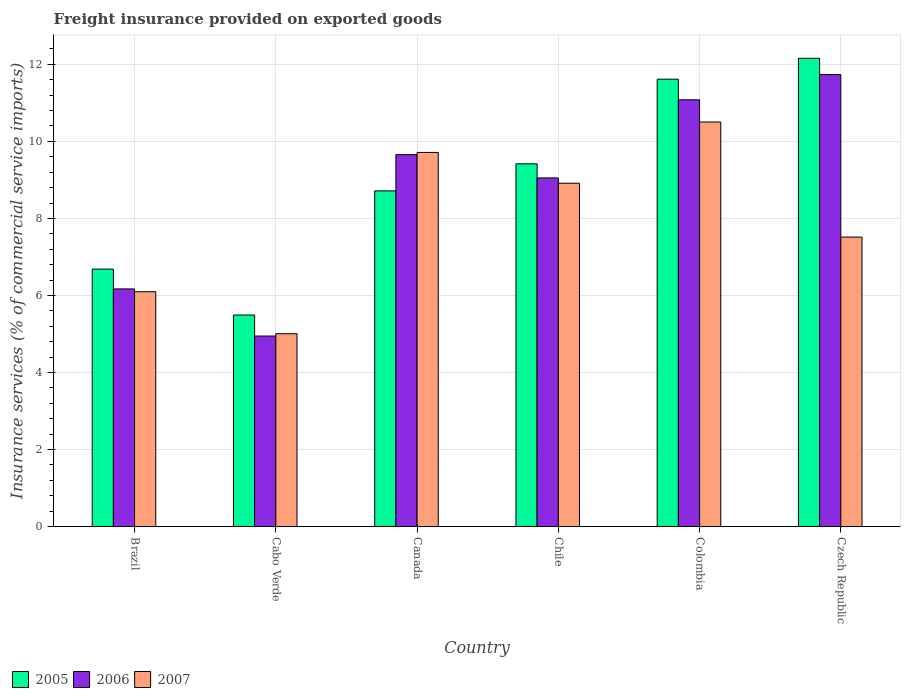How many groups of bars are there?
Your answer should be compact. 6. Are the number of bars per tick equal to the number of legend labels?
Make the answer very short. Yes. How many bars are there on the 2nd tick from the left?
Make the answer very short. 3. In how many cases, is the number of bars for a given country not equal to the number of legend labels?
Your answer should be very brief. 0. What is the freight insurance provided on exported goods in 2006 in Chile?
Offer a terse response. 9.05. Across all countries, what is the maximum freight insurance provided on exported goods in 2006?
Keep it short and to the point. 11.73. Across all countries, what is the minimum freight insurance provided on exported goods in 2005?
Your answer should be compact. 5.49. In which country was the freight insurance provided on exported goods in 2007 maximum?
Give a very brief answer. Colombia. In which country was the freight insurance provided on exported goods in 2007 minimum?
Your answer should be compact. Cabo Verde. What is the total freight insurance provided on exported goods in 2006 in the graph?
Offer a very short reply. 52.64. What is the difference between the freight insurance provided on exported goods in 2005 in Cabo Verde and that in Colombia?
Your answer should be compact. -6.12. What is the difference between the freight insurance provided on exported goods in 2005 in Chile and the freight insurance provided on exported goods in 2007 in Czech Republic?
Your answer should be very brief. 1.9. What is the average freight insurance provided on exported goods in 2005 per country?
Ensure brevity in your answer.  9.01. What is the difference between the freight insurance provided on exported goods of/in 2005 and freight insurance provided on exported goods of/in 2007 in Czech Republic?
Ensure brevity in your answer.  4.64. In how many countries, is the freight insurance provided on exported goods in 2006 greater than 11.2 %?
Offer a terse response. 1. What is the ratio of the freight insurance provided on exported goods in 2006 in Colombia to that in Czech Republic?
Ensure brevity in your answer.  0.94. Is the freight insurance provided on exported goods in 2005 in Brazil less than that in Canada?
Give a very brief answer. Yes. What is the difference between the highest and the second highest freight insurance provided on exported goods in 2007?
Provide a succinct answer. -0.8. What is the difference between the highest and the lowest freight insurance provided on exported goods in 2006?
Give a very brief answer. 6.79. In how many countries, is the freight insurance provided on exported goods in 2007 greater than the average freight insurance provided on exported goods in 2007 taken over all countries?
Make the answer very short. 3. Is the sum of the freight insurance provided on exported goods in 2005 in Brazil and Czech Republic greater than the maximum freight insurance provided on exported goods in 2007 across all countries?
Offer a very short reply. Yes. What does the 2nd bar from the right in Cabo Verde represents?
Keep it short and to the point. 2006. Is it the case that in every country, the sum of the freight insurance provided on exported goods in 2007 and freight insurance provided on exported goods in 2005 is greater than the freight insurance provided on exported goods in 2006?
Offer a very short reply. Yes. How many bars are there?
Offer a very short reply. 18. How many countries are there in the graph?
Provide a succinct answer. 6. What is the difference between two consecutive major ticks on the Y-axis?
Offer a very short reply. 2. Are the values on the major ticks of Y-axis written in scientific E-notation?
Offer a terse response. No. Does the graph contain grids?
Provide a short and direct response. Yes. How many legend labels are there?
Ensure brevity in your answer.  3. What is the title of the graph?
Ensure brevity in your answer.  Freight insurance provided on exported goods. What is the label or title of the X-axis?
Provide a short and direct response. Country. What is the label or title of the Y-axis?
Your answer should be compact. Insurance services (% of commercial service imports). What is the Insurance services (% of commercial service imports) of 2005 in Brazil?
Offer a terse response. 6.68. What is the Insurance services (% of commercial service imports) of 2006 in Brazil?
Make the answer very short. 6.17. What is the Insurance services (% of commercial service imports) in 2007 in Brazil?
Offer a very short reply. 6.1. What is the Insurance services (% of commercial service imports) in 2005 in Cabo Verde?
Make the answer very short. 5.49. What is the Insurance services (% of commercial service imports) of 2006 in Cabo Verde?
Keep it short and to the point. 4.95. What is the Insurance services (% of commercial service imports) in 2007 in Cabo Verde?
Offer a terse response. 5.01. What is the Insurance services (% of commercial service imports) in 2005 in Canada?
Your response must be concise. 8.72. What is the Insurance services (% of commercial service imports) of 2006 in Canada?
Make the answer very short. 9.66. What is the Insurance services (% of commercial service imports) in 2007 in Canada?
Your response must be concise. 9.71. What is the Insurance services (% of commercial service imports) in 2005 in Chile?
Give a very brief answer. 9.42. What is the Insurance services (% of commercial service imports) of 2006 in Chile?
Offer a very short reply. 9.05. What is the Insurance services (% of commercial service imports) of 2007 in Chile?
Provide a short and direct response. 8.91. What is the Insurance services (% of commercial service imports) in 2005 in Colombia?
Give a very brief answer. 11.62. What is the Insurance services (% of commercial service imports) in 2006 in Colombia?
Offer a very short reply. 11.08. What is the Insurance services (% of commercial service imports) of 2007 in Colombia?
Your answer should be very brief. 10.5. What is the Insurance services (% of commercial service imports) of 2005 in Czech Republic?
Keep it short and to the point. 12.16. What is the Insurance services (% of commercial service imports) of 2006 in Czech Republic?
Provide a short and direct response. 11.73. What is the Insurance services (% of commercial service imports) of 2007 in Czech Republic?
Keep it short and to the point. 7.51. Across all countries, what is the maximum Insurance services (% of commercial service imports) in 2005?
Keep it short and to the point. 12.16. Across all countries, what is the maximum Insurance services (% of commercial service imports) in 2006?
Give a very brief answer. 11.73. Across all countries, what is the maximum Insurance services (% of commercial service imports) in 2007?
Keep it short and to the point. 10.5. Across all countries, what is the minimum Insurance services (% of commercial service imports) in 2005?
Your answer should be compact. 5.49. Across all countries, what is the minimum Insurance services (% of commercial service imports) of 2006?
Provide a short and direct response. 4.95. Across all countries, what is the minimum Insurance services (% of commercial service imports) in 2007?
Give a very brief answer. 5.01. What is the total Insurance services (% of commercial service imports) in 2005 in the graph?
Provide a short and direct response. 54.08. What is the total Insurance services (% of commercial service imports) in 2006 in the graph?
Your answer should be very brief. 52.64. What is the total Insurance services (% of commercial service imports) in 2007 in the graph?
Your answer should be compact. 47.75. What is the difference between the Insurance services (% of commercial service imports) of 2005 in Brazil and that in Cabo Verde?
Keep it short and to the point. 1.19. What is the difference between the Insurance services (% of commercial service imports) in 2006 in Brazil and that in Cabo Verde?
Provide a short and direct response. 1.22. What is the difference between the Insurance services (% of commercial service imports) in 2007 in Brazil and that in Cabo Verde?
Keep it short and to the point. 1.09. What is the difference between the Insurance services (% of commercial service imports) of 2005 in Brazil and that in Canada?
Your response must be concise. -2.03. What is the difference between the Insurance services (% of commercial service imports) in 2006 in Brazil and that in Canada?
Provide a short and direct response. -3.49. What is the difference between the Insurance services (% of commercial service imports) of 2007 in Brazil and that in Canada?
Provide a succinct answer. -3.62. What is the difference between the Insurance services (% of commercial service imports) in 2005 in Brazil and that in Chile?
Make the answer very short. -2.73. What is the difference between the Insurance services (% of commercial service imports) in 2006 in Brazil and that in Chile?
Your response must be concise. -2.88. What is the difference between the Insurance services (% of commercial service imports) in 2007 in Brazil and that in Chile?
Keep it short and to the point. -2.82. What is the difference between the Insurance services (% of commercial service imports) in 2005 in Brazil and that in Colombia?
Provide a short and direct response. -4.93. What is the difference between the Insurance services (% of commercial service imports) of 2006 in Brazil and that in Colombia?
Give a very brief answer. -4.91. What is the difference between the Insurance services (% of commercial service imports) in 2007 in Brazil and that in Colombia?
Provide a short and direct response. -4.41. What is the difference between the Insurance services (% of commercial service imports) of 2005 in Brazil and that in Czech Republic?
Make the answer very short. -5.47. What is the difference between the Insurance services (% of commercial service imports) in 2006 in Brazil and that in Czech Republic?
Offer a terse response. -5.57. What is the difference between the Insurance services (% of commercial service imports) of 2007 in Brazil and that in Czech Republic?
Offer a very short reply. -1.42. What is the difference between the Insurance services (% of commercial service imports) of 2005 in Cabo Verde and that in Canada?
Provide a succinct answer. -3.22. What is the difference between the Insurance services (% of commercial service imports) of 2006 in Cabo Verde and that in Canada?
Keep it short and to the point. -4.71. What is the difference between the Insurance services (% of commercial service imports) in 2007 in Cabo Verde and that in Canada?
Make the answer very short. -4.71. What is the difference between the Insurance services (% of commercial service imports) of 2005 in Cabo Verde and that in Chile?
Offer a terse response. -3.93. What is the difference between the Insurance services (% of commercial service imports) of 2006 in Cabo Verde and that in Chile?
Give a very brief answer. -4.11. What is the difference between the Insurance services (% of commercial service imports) of 2007 in Cabo Verde and that in Chile?
Your answer should be very brief. -3.91. What is the difference between the Insurance services (% of commercial service imports) in 2005 in Cabo Verde and that in Colombia?
Keep it short and to the point. -6.12. What is the difference between the Insurance services (% of commercial service imports) in 2006 in Cabo Verde and that in Colombia?
Your response must be concise. -6.13. What is the difference between the Insurance services (% of commercial service imports) of 2007 in Cabo Verde and that in Colombia?
Make the answer very short. -5.5. What is the difference between the Insurance services (% of commercial service imports) of 2005 in Cabo Verde and that in Czech Republic?
Make the answer very short. -6.67. What is the difference between the Insurance services (% of commercial service imports) of 2006 in Cabo Verde and that in Czech Republic?
Make the answer very short. -6.79. What is the difference between the Insurance services (% of commercial service imports) in 2007 in Cabo Verde and that in Czech Republic?
Offer a terse response. -2.51. What is the difference between the Insurance services (% of commercial service imports) of 2005 in Canada and that in Chile?
Give a very brief answer. -0.7. What is the difference between the Insurance services (% of commercial service imports) of 2006 in Canada and that in Chile?
Your response must be concise. 0.6. What is the difference between the Insurance services (% of commercial service imports) of 2007 in Canada and that in Chile?
Your answer should be compact. 0.8. What is the difference between the Insurance services (% of commercial service imports) of 2006 in Canada and that in Colombia?
Your response must be concise. -1.42. What is the difference between the Insurance services (% of commercial service imports) of 2007 in Canada and that in Colombia?
Your response must be concise. -0.79. What is the difference between the Insurance services (% of commercial service imports) in 2005 in Canada and that in Czech Republic?
Give a very brief answer. -3.44. What is the difference between the Insurance services (% of commercial service imports) of 2006 in Canada and that in Czech Republic?
Your answer should be very brief. -2.08. What is the difference between the Insurance services (% of commercial service imports) in 2007 in Canada and that in Czech Republic?
Offer a very short reply. 2.2. What is the difference between the Insurance services (% of commercial service imports) of 2005 in Chile and that in Colombia?
Your answer should be compact. -2.2. What is the difference between the Insurance services (% of commercial service imports) in 2006 in Chile and that in Colombia?
Ensure brevity in your answer.  -2.03. What is the difference between the Insurance services (% of commercial service imports) of 2007 in Chile and that in Colombia?
Your answer should be compact. -1.59. What is the difference between the Insurance services (% of commercial service imports) of 2005 in Chile and that in Czech Republic?
Keep it short and to the point. -2.74. What is the difference between the Insurance services (% of commercial service imports) in 2006 in Chile and that in Czech Republic?
Offer a very short reply. -2.68. What is the difference between the Insurance services (% of commercial service imports) of 2007 in Chile and that in Czech Republic?
Make the answer very short. 1.4. What is the difference between the Insurance services (% of commercial service imports) in 2005 in Colombia and that in Czech Republic?
Your answer should be compact. -0.54. What is the difference between the Insurance services (% of commercial service imports) of 2006 in Colombia and that in Czech Republic?
Ensure brevity in your answer.  -0.66. What is the difference between the Insurance services (% of commercial service imports) of 2007 in Colombia and that in Czech Republic?
Your answer should be very brief. 2.99. What is the difference between the Insurance services (% of commercial service imports) of 2005 in Brazil and the Insurance services (% of commercial service imports) of 2006 in Cabo Verde?
Ensure brevity in your answer.  1.74. What is the difference between the Insurance services (% of commercial service imports) of 2005 in Brazil and the Insurance services (% of commercial service imports) of 2007 in Cabo Verde?
Give a very brief answer. 1.68. What is the difference between the Insurance services (% of commercial service imports) of 2006 in Brazil and the Insurance services (% of commercial service imports) of 2007 in Cabo Verde?
Make the answer very short. 1.16. What is the difference between the Insurance services (% of commercial service imports) of 2005 in Brazil and the Insurance services (% of commercial service imports) of 2006 in Canada?
Keep it short and to the point. -2.97. What is the difference between the Insurance services (% of commercial service imports) in 2005 in Brazil and the Insurance services (% of commercial service imports) in 2007 in Canada?
Ensure brevity in your answer.  -3.03. What is the difference between the Insurance services (% of commercial service imports) of 2006 in Brazil and the Insurance services (% of commercial service imports) of 2007 in Canada?
Provide a short and direct response. -3.54. What is the difference between the Insurance services (% of commercial service imports) in 2005 in Brazil and the Insurance services (% of commercial service imports) in 2006 in Chile?
Ensure brevity in your answer.  -2.37. What is the difference between the Insurance services (% of commercial service imports) of 2005 in Brazil and the Insurance services (% of commercial service imports) of 2007 in Chile?
Your answer should be compact. -2.23. What is the difference between the Insurance services (% of commercial service imports) in 2006 in Brazil and the Insurance services (% of commercial service imports) in 2007 in Chile?
Give a very brief answer. -2.74. What is the difference between the Insurance services (% of commercial service imports) of 2005 in Brazil and the Insurance services (% of commercial service imports) of 2006 in Colombia?
Provide a succinct answer. -4.4. What is the difference between the Insurance services (% of commercial service imports) of 2005 in Brazil and the Insurance services (% of commercial service imports) of 2007 in Colombia?
Your response must be concise. -3.82. What is the difference between the Insurance services (% of commercial service imports) in 2006 in Brazil and the Insurance services (% of commercial service imports) in 2007 in Colombia?
Make the answer very short. -4.33. What is the difference between the Insurance services (% of commercial service imports) in 2005 in Brazil and the Insurance services (% of commercial service imports) in 2006 in Czech Republic?
Offer a very short reply. -5.05. What is the difference between the Insurance services (% of commercial service imports) of 2005 in Brazil and the Insurance services (% of commercial service imports) of 2007 in Czech Republic?
Make the answer very short. -0.83. What is the difference between the Insurance services (% of commercial service imports) of 2006 in Brazil and the Insurance services (% of commercial service imports) of 2007 in Czech Republic?
Provide a short and direct response. -1.35. What is the difference between the Insurance services (% of commercial service imports) in 2005 in Cabo Verde and the Insurance services (% of commercial service imports) in 2006 in Canada?
Provide a short and direct response. -4.16. What is the difference between the Insurance services (% of commercial service imports) in 2005 in Cabo Verde and the Insurance services (% of commercial service imports) in 2007 in Canada?
Give a very brief answer. -4.22. What is the difference between the Insurance services (% of commercial service imports) in 2006 in Cabo Verde and the Insurance services (% of commercial service imports) in 2007 in Canada?
Keep it short and to the point. -4.77. What is the difference between the Insurance services (% of commercial service imports) in 2005 in Cabo Verde and the Insurance services (% of commercial service imports) in 2006 in Chile?
Your answer should be compact. -3.56. What is the difference between the Insurance services (% of commercial service imports) of 2005 in Cabo Verde and the Insurance services (% of commercial service imports) of 2007 in Chile?
Offer a terse response. -3.42. What is the difference between the Insurance services (% of commercial service imports) of 2006 in Cabo Verde and the Insurance services (% of commercial service imports) of 2007 in Chile?
Offer a terse response. -3.97. What is the difference between the Insurance services (% of commercial service imports) in 2005 in Cabo Verde and the Insurance services (% of commercial service imports) in 2006 in Colombia?
Your answer should be compact. -5.59. What is the difference between the Insurance services (% of commercial service imports) of 2005 in Cabo Verde and the Insurance services (% of commercial service imports) of 2007 in Colombia?
Give a very brief answer. -5.01. What is the difference between the Insurance services (% of commercial service imports) of 2006 in Cabo Verde and the Insurance services (% of commercial service imports) of 2007 in Colombia?
Offer a very short reply. -5.56. What is the difference between the Insurance services (% of commercial service imports) in 2005 in Cabo Verde and the Insurance services (% of commercial service imports) in 2006 in Czech Republic?
Your answer should be compact. -6.24. What is the difference between the Insurance services (% of commercial service imports) in 2005 in Cabo Verde and the Insurance services (% of commercial service imports) in 2007 in Czech Republic?
Make the answer very short. -2.02. What is the difference between the Insurance services (% of commercial service imports) of 2006 in Cabo Verde and the Insurance services (% of commercial service imports) of 2007 in Czech Republic?
Offer a terse response. -2.57. What is the difference between the Insurance services (% of commercial service imports) of 2005 in Canada and the Insurance services (% of commercial service imports) of 2006 in Chile?
Keep it short and to the point. -0.34. What is the difference between the Insurance services (% of commercial service imports) of 2005 in Canada and the Insurance services (% of commercial service imports) of 2007 in Chile?
Ensure brevity in your answer.  -0.2. What is the difference between the Insurance services (% of commercial service imports) of 2006 in Canada and the Insurance services (% of commercial service imports) of 2007 in Chile?
Provide a succinct answer. 0.74. What is the difference between the Insurance services (% of commercial service imports) in 2005 in Canada and the Insurance services (% of commercial service imports) in 2006 in Colombia?
Your answer should be compact. -2.36. What is the difference between the Insurance services (% of commercial service imports) of 2005 in Canada and the Insurance services (% of commercial service imports) of 2007 in Colombia?
Your answer should be compact. -1.79. What is the difference between the Insurance services (% of commercial service imports) in 2006 in Canada and the Insurance services (% of commercial service imports) in 2007 in Colombia?
Provide a short and direct response. -0.85. What is the difference between the Insurance services (% of commercial service imports) in 2005 in Canada and the Insurance services (% of commercial service imports) in 2006 in Czech Republic?
Keep it short and to the point. -3.02. What is the difference between the Insurance services (% of commercial service imports) in 2005 in Canada and the Insurance services (% of commercial service imports) in 2007 in Czech Republic?
Make the answer very short. 1.2. What is the difference between the Insurance services (% of commercial service imports) of 2006 in Canada and the Insurance services (% of commercial service imports) of 2007 in Czech Republic?
Your answer should be very brief. 2.14. What is the difference between the Insurance services (% of commercial service imports) in 2005 in Chile and the Insurance services (% of commercial service imports) in 2006 in Colombia?
Your response must be concise. -1.66. What is the difference between the Insurance services (% of commercial service imports) of 2005 in Chile and the Insurance services (% of commercial service imports) of 2007 in Colombia?
Offer a very short reply. -1.09. What is the difference between the Insurance services (% of commercial service imports) in 2006 in Chile and the Insurance services (% of commercial service imports) in 2007 in Colombia?
Give a very brief answer. -1.45. What is the difference between the Insurance services (% of commercial service imports) in 2005 in Chile and the Insurance services (% of commercial service imports) in 2006 in Czech Republic?
Keep it short and to the point. -2.32. What is the difference between the Insurance services (% of commercial service imports) of 2005 in Chile and the Insurance services (% of commercial service imports) of 2007 in Czech Republic?
Your response must be concise. 1.9. What is the difference between the Insurance services (% of commercial service imports) of 2006 in Chile and the Insurance services (% of commercial service imports) of 2007 in Czech Republic?
Ensure brevity in your answer.  1.54. What is the difference between the Insurance services (% of commercial service imports) in 2005 in Colombia and the Insurance services (% of commercial service imports) in 2006 in Czech Republic?
Offer a very short reply. -0.12. What is the difference between the Insurance services (% of commercial service imports) of 2005 in Colombia and the Insurance services (% of commercial service imports) of 2007 in Czech Republic?
Offer a very short reply. 4.1. What is the difference between the Insurance services (% of commercial service imports) in 2006 in Colombia and the Insurance services (% of commercial service imports) in 2007 in Czech Republic?
Provide a succinct answer. 3.56. What is the average Insurance services (% of commercial service imports) of 2005 per country?
Give a very brief answer. 9.01. What is the average Insurance services (% of commercial service imports) of 2006 per country?
Provide a short and direct response. 8.77. What is the average Insurance services (% of commercial service imports) in 2007 per country?
Offer a terse response. 7.96. What is the difference between the Insurance services (% of commercial service imports) in 2005 and Insurance services (% of commercial service imports) in 2006 in Brazil?
Keep it short and to the point. 0.51. What is the difference between the Insurance services (% of commercial service imports) of 2005 and Insurance services (% of commercial service imports) of 2007 in Brazil?
Offer a terse response. 0.59. What is the difference between the Insurance services (% of commercial service imports) in 2006 and Insurance services (% of commercial service imports) in 2007 in Brazil?
Ensure brevity in your answer.  0.07. What is the difference between the Insurance services (% of commercial service imports) of 2005 and Insurance services (% of commercial service imports) of 2006 in Cabo Verde?
Your answer should be compact. 0.55. What is the difference between the Insurance services (% of commercial service imports) in 2005 and Insurance services (% of commercial service imports) in 2007 in Cabo Verde?
Keep it short and to the point. 0.49. What is the difference between the Insurance services (% of commercial service imports) in 2006 and Insurance services (% of commercial service imports) in 2007 in Cabo Verde?
Make the answer very short. -0.06. What is the difference between the Insurance services (% of commercial service imports) in 2005 and Insurance services (% of commercial service imports) in 2006 in Canada?
Your response must be concise. -0.94. What is the difference between the Insurance services (% of commercial service imports) of 2005 and Insurance services (% of commercial service imports) of 2007 in Canada?
Give a very brief answer. -1. What is the difference between the Insurance services (% of commercial service imports) of 2006 and Insurance services (% of commercial service imports) of 2007 in Canada?
Offer a very short reply. -0.06. What is the difference between the Insurance services (% of commercial service imports) in 2005 and Insurance services (% of commercial service imports) in 2006 in Chile?
Provide a short and direct response. 0.37. What is the difference between the Insurance services (% of commercial service imports) of 2005 and Insurance services (% of commercial service imports) of 2007 in Chile?
Offer a terse response. 0.5. What is the difference between the Insurance services (% of commercial service imports) in 2006 and Insurance services (% of commercial service imports) in 2007 in Chile?
Offer a very short reply. 0.14. What is the difference between the Insurance services (% of commercial service imports) of 2005 and Insurance services (% of commercial service imports) of 2006 in Colombia?
Offer a very short reply. 0.54. What is the difference between the Insurance services (% of commercial service imports) of 2005 and Insurance services (% of commercial service imports) of 2007 in Colombia?
Provide a short and direct response. 1.11. What is the difference between the Insurance services (% of commercial service imports) of 2006 and Insurance services (% of commercial service imports) of 2007 in Colombia?
Provide a succinct answer. 0.58. What is the difference between the Insurance services (% of commercial service imports) in 2005 and Insurance services (% of commercial service imports) in 2006 in Czech Republic?
Offer a very short reply. 0.42. What is the difference between the Insurance services (% of commercial service imports) of 2005 and Insurance services (% of commercial service imports) of 2007 in Czech Republic?
Your response must be concise. 4.64. What is the difference between the Insurance services (% of commercial service imports) of 2006 and Insurance services (% of commercial service imports) of 2007 in Czech Republic?
Provide a succinct answer. 4.22. What is the ratio of the Insurance services (% of commercial service imports) in 2005 in Brazil to that in Cabo Verde?
Ensure brevity in your answer.  1.22. What is the ratio of the Insurance services (% of commercial service imports) in 2006 in Brazil to that in Cabo Verde?
Give a very brief answer. 1.25. What is the ratio of the Insurance services (% of commercial service imports) of 2007 in Brazil to that in Cabo Verde?
Your answer should be compact. 1.22. What is the ratio of the Insurance services (% of commercial service imports) in 2005 in Brazil to that in Canada?
Keep it short and to the point. 0.77. What is the ratio of the Insurance services (% of commercial service imports) in 2006 in Brazil to that in Canada?
Offer a terse response. 0.64. What is the ratio of the Insurance services (% of commercial service imports) in 2007 in Brazil to that in Canada?
Offer a very short reply. 0.63. What is the ratio of the Insurance services (% of commercial service imports) in 2005 in Brazil to that in Chile?
Keep it short and to the point. 0.71. What is the ratio of the Insurance services (% of commercial service imports) of 2006 in Brazil to that in Chile?
Make the answer very short. 0.68. What is the ratio of the Insurance services (% of commercial service imports) of 2007 in Brazil to that in Chile?
Provide a succinct answer. 0.68. What is the ratio of the Insurance services (% of commercial service imports) of 2005 in Brazil to that in Colombia?
Make the answer very short. 0.58. What is the ratio of the Insurance services (% of commercial service imports) in 2006 in Brazil to that in Colombia?
Offer a terse response. 0.56. What is the ratio of the Insurance services (% of commercial service imports) of 2007 in Brazil to that in Colombia?
Keep it short and to the point. 0.58. What is the ratio of the Insurance services (% of commercial service imports) in 2005 in Brazil to that in Czech Republic?
Offer a terse response. 0.55. What is the ratio of the Insurance services (% of commercial service imports) in 2006 in Brazil to that in Czech Republic?
Your answer should be very brief. 0.53. What is the ratio of the Insurance services (% of commercial service imports) in 2007 in Brazil to that in Czech Republic?
Provide a succinct answer. 0.81. What is the ratio of the Insurance services (% of commercial service imports) in 2005 in Cabo Verde to that in Canada?
Provide a succinct answer. 0.63. What is the ratio of the Insurance services (% of commercial service imports) of 2006 in Cabo Verde to that in Canada?
Provide a succinct answer. 0.51. What is the ratio of the Insurance services (% of commercial service imports) of 2007 in Cabo Verde to that in Canada?
Your response must be concise. 0.52. What is the ratio of the Insurance services (% of commercial service imports) of 2005 in Cabo Verde to that in Chile?
Offer a very short reply. 0.58. What is the ratio of the Insurance services (% of commercial service imports) in 2006 in Cabo Verde to that in Chile?
Ensure brevity in your answer.  0.55. What is the ratio of the Insurance services (% of commercial service imports) of 2007 in Cabo Verde to that in Chile?
Offer a terse response. 0.56. What is the ratio of the Insurance services (% of commercial service imports) in 2005 in Cabo Verde to that in Colombia?
Offer a terse response. 0.47. What is the ratio of the Insurance services (% of commercial service imports) of 2006 in Cabo Verde to that in Colombia?
Keep it short and to the point. 0.45. What is the ratio of the Insurance services (% of commercial service imports) in 2007 in Cabo Verde to that in Colombia?
Ensure brevity in your answer.  0.48. What is the ratio of the Insurance services (% of commercial service imports) of 2005 in Cabo Verde to that in Czech Republic?
Give a very brief answer. 0.45. What is the ratio of the Insurance services (% of commercial service imports) in 2006 in Cabo Verde to that in Czech Republic?
Your response must be concise. 0.42. What is the ratio of the Insurance services (% of commercial service imports) in 2007 in Cabo Verde to that in Czech Republic?
Make the answer very short. 0.67. What is the ratio of the Insurance services (% of commercial service imports) of 2005 in Canada to that in Chile?
Your answer should be very brief. 0.93. What is the ratio of the Insurance services (% of commercial service imports) of 2006 in Canada to that in Chile?
Your answer should be very brief. 1.07. What is the ratio of the Insurance services (% of commercial service imports) of 2007 in Canada to that in Chile?
Make the answer very short. 1.09. What is the ratio of the Insurance services (% of commercial service imports) of 2005 in Canada to that in Colombia?
Keep it short and to the point. 0.75. What is the ratio of the Insurance services (% of commercial service imports) of 2006 in Canada to that in Colombia?
Offer a terse response. 0.87. What is the ratio of the Insurance services (% of commercial service imports) of 2007 in Canada to that in Colombia?
Keep it short and to the point. 0.92. What is the ratio of the Insurance services (% of commercial service imports) in 2005 in Canada to that in Czech Republic?
Your response must be concise. 0.72. What is the ratio of the Insurance services (% of commercial service imports) in 2006 in Canada to that in Czech Republic?
Ensure brevity in your answer.  0.82. What is the ratio of the Insurance services (% of commercial service imports) in 2007 in Canada to that in Czech Republic?
Your answer should be very brief. 1.29. What is the ratio of the Insurance services (% of commercial service imports) of 2005 in Chile to that in Colombia?
Give a very brief answer. 0.81. What is the ratio of the Insurance services (% of commercial service imports) in 2006 in Chile to that in Colombia?
Offer a very short reply. 0.82. What is the ratio of the Insurance services (% of commercial service imports) in 2007 in Chile to that in Colombia?
Offer a very short reply. 0.85. What is the ratio of the Insurance services (% of commercial service imports) in 2005 in Chile to that in Czech Republic?
Keep it short and to the point. 0.77. What is the ratio of the Insurance services (% of commercial service imports) in 2006 in Chile to that in Czech Republic?
Ensure brevity in your answer.  0.77. What is the ratio of the Insurance services (% of commercial service imports) of 2007 in Chile to that in Czech Republic?
Keep it short and to the point. 1.19. What is the ratio of the Insurance services (% of commercial service imports) in 2005 in Colombia to that in Czech Republic?
Your answer should be compact. 0.96. What is the ratio of the Insurance services (% of commercial service imports) in 2006 in Colombia to that in Czech Republic?
Your answer should be compact. 0.94. What is the ratio of the Insurance services (% of commercial service imports) in 2007 in Colombia to that in Czech Republic?
Your response must be concise. 1.4. What is the difference between the highest and the second highest Insurance services (% of commercial service imports) in 2005?
Offer a very short reply. 0.54. What is the difference between the highest and the second highest Insurance services (% of commercial service imports) in 2006?
Your answer should be compact. 0.66. What is the difference between the highest and the second highest Insurance services (% of commercial service imports) in 2007?
Provide a short and direct response. 0.79. What is the difference between the highest and the lowest Insurance services (% of commercial service imports) in 2006?
Your response must be concise. 6.79. What is the difference between the highest and the lowest Insurance services (% of commercial service imports) of 2007?
Your answer should be very brief. 5.5. 